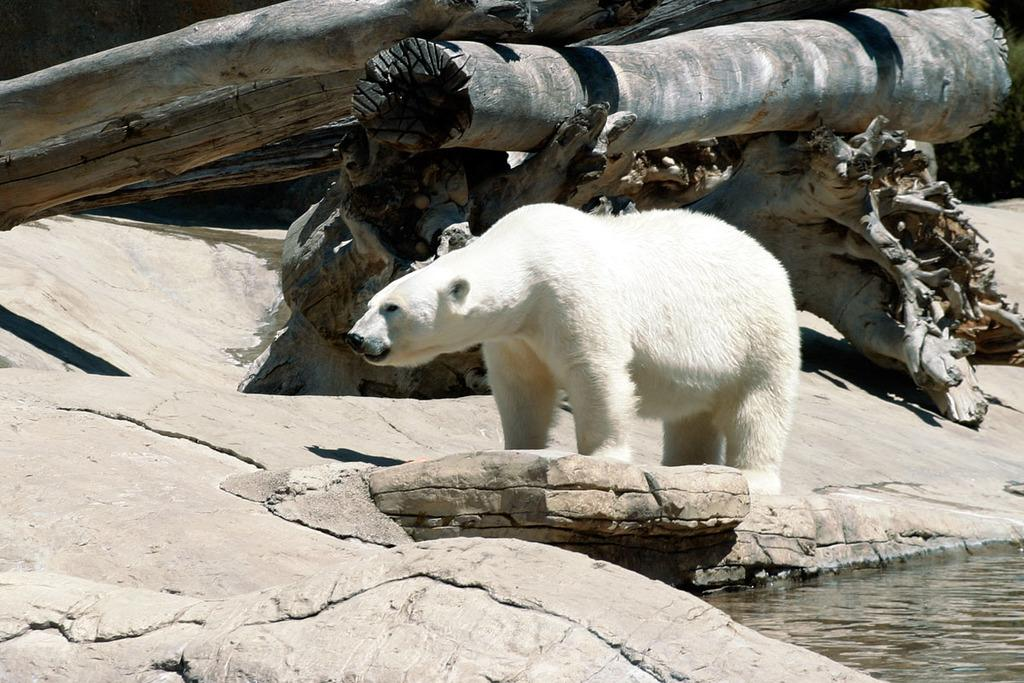What animal is the main subject of the image? There is a polar bear in the image. What is the polar bear standing on? The polar bear is standing on a rock. What can be seen in the bottom right corner of the image? There is water in the bottom right corner of the image. What is located behind the polar bear? There are wooden logs behind the polar bear. What news headline is displayed on the polar bear's forehead in the image? There is no news headline displayed on the polar bear's forehead in the image. 